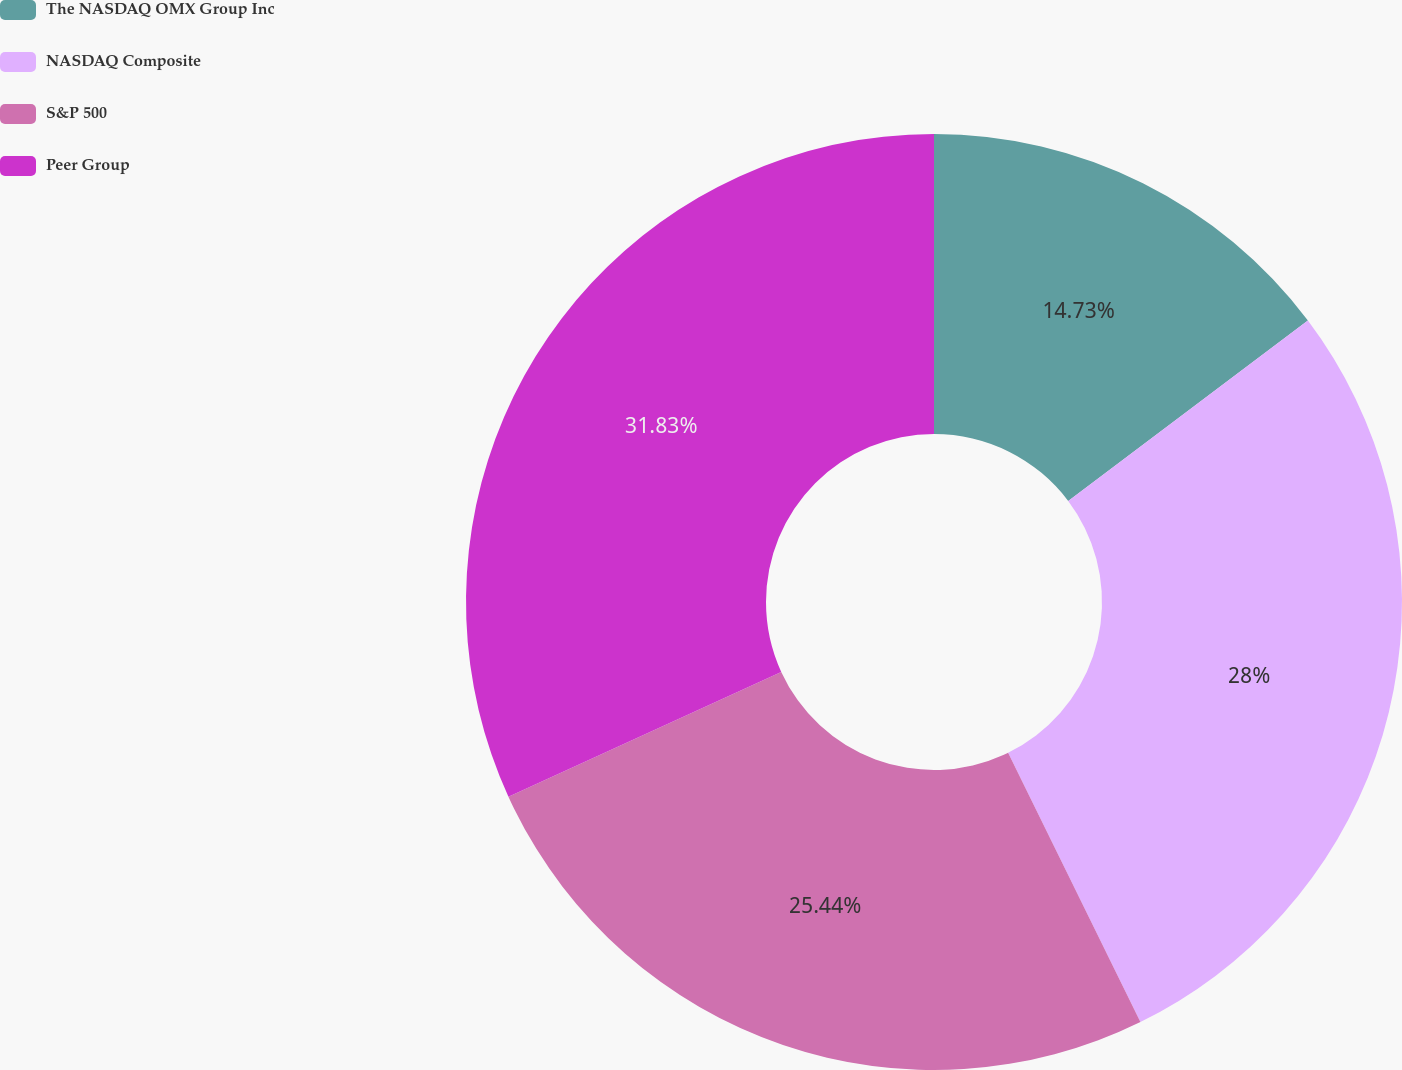Convert chart. <chart><loc_0><loc_0><loc_500><loc_500><pie_chart><fcel>The NASDAQ OMX Group Inc<fcel>NASDAQ Composite<fcel>S&P 500<fcel>Peer Group<nl><fcel>14.73%<fcel>28.0%<fcel>25.44%<fcel>31.83%<nl></chart> 